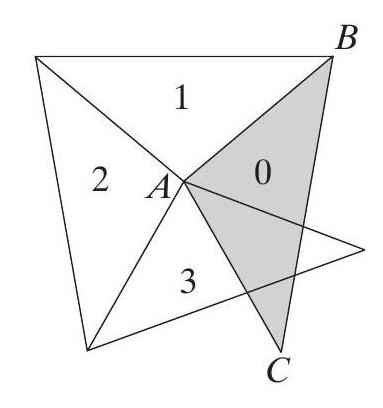How can the arrangement of these triangles help in real-world applications or understanding of geometry? This arrangement of triangles is a practical visualization of concepts in geometry like rotational symmetry and tessellation, which are applicable in fields such as architectural design, graphic art, and even crystallography. Understanding how shapes can fit together without gaps or overlaps is vital for these fields, making this a useful geometric exercise. 